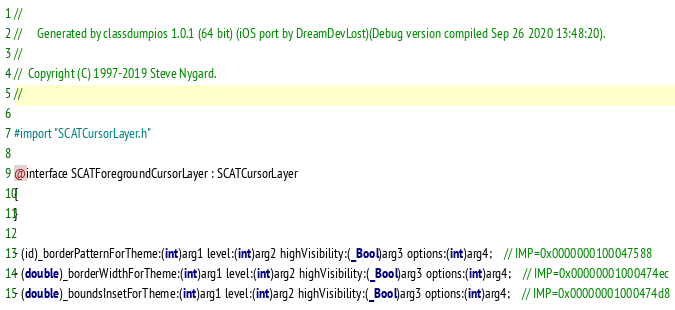Convert code to text. <code><loc_0><loc_0><loc_500><loc_500><_C_>//
//     Generated by classdumpios 1.0.1 (64 bit) (iOS port by DreamDevLost)(Debug version compiled Sep 26 2020 13:48:20).
//
//  Copyright (C) 1997-2019 Steve Nygard.
//

#import "SCATCursorLayer.h"

@interface SCATForegroundCursorLayer : SCATCursorLayer
{
}

- (id)_borderPatternForTheme:(int)arg1 level:(int)arg2 highVisibility:(_Bool)arg3 options:(int)arg4;	// IMP=0x0000000100047588
- (double)_borderWidthForTheme:(int)arg1 level:(int)arg2 highVisibility:(_Bool)arg3 options:(int)arg4;	// IMP=0x00000001000474ec
- (double)_boundsInsetForTheme:(int)arg1 level:(int)arg2 highVisibility:(_Bool)arg3 options:(int)arg4;	// IMP=0x00000001000474d8</code> 